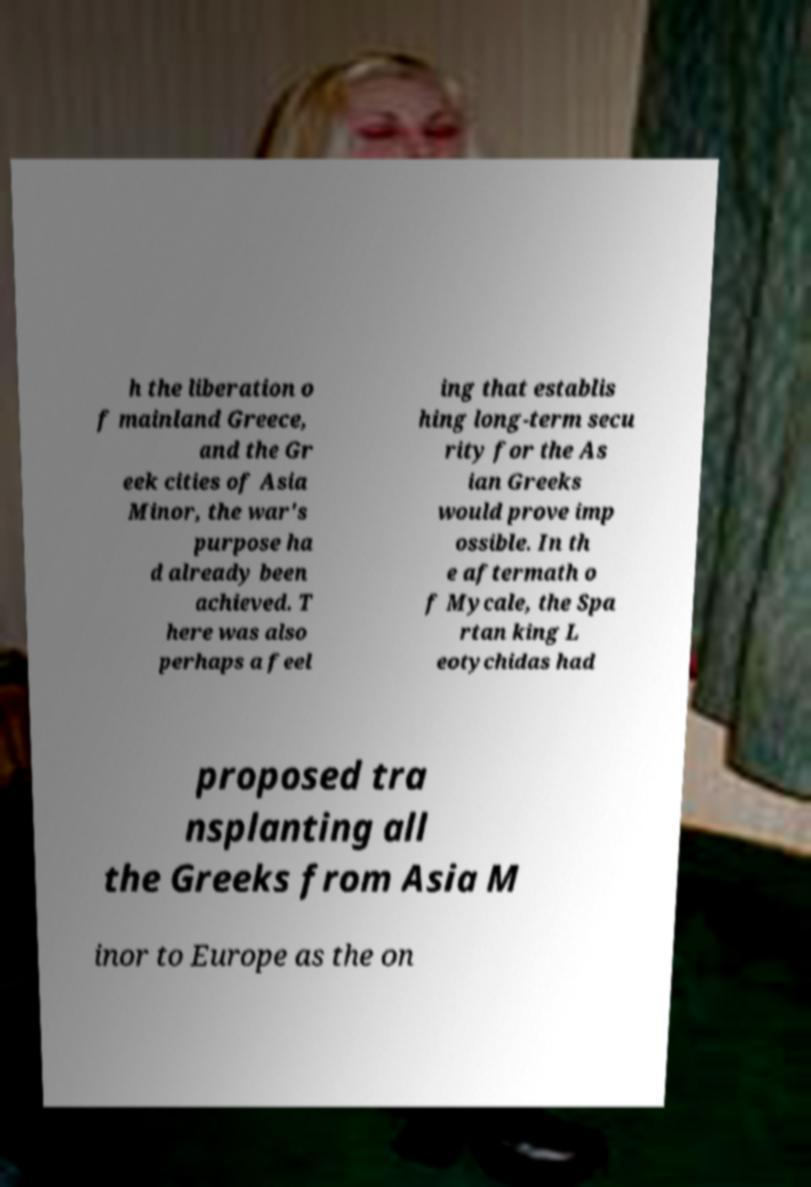Please identify and transcribe the text found in this image. h the liberation o f mainland Greece, and the Gr eek cities of Asia Minor, the war's purpose ha d already been achieved. T here was also perhaps a feel ing that establis hing long-term secu rity for the As ian Greeks would prove imp ossible. In th e aftermath o f Mycale, the Spa rtan king L eotychidas had proposed tra nsplanting all the Greeks from Asia M inor to Europe as the on 